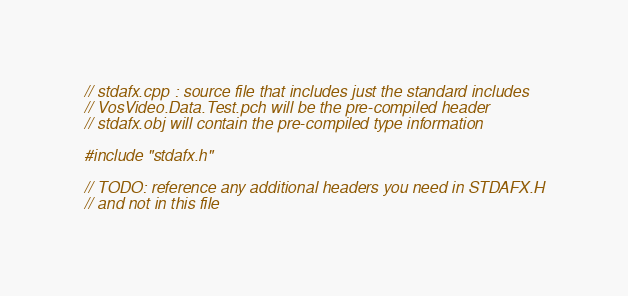<code> <loc_0><loc_0><loc_500><loc_500><_C++_>// stdafx.cpp : source file that includes just the standard includes
// VosVideo.Data.Test.pch will be the pre-compiled header
// stdafx.obj will contain the pre-compiled type information

#include "stdafx.h"

// TODO: reference any additional headers you need in STDAFX.H
// and not in this file
</code> 